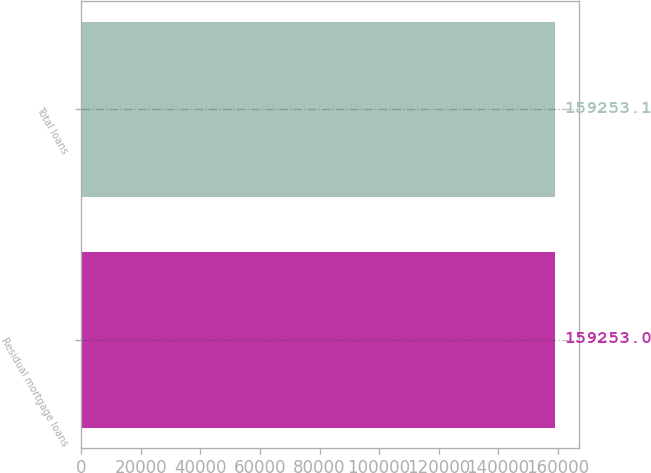Convert chart. <chart><loc_0><loc_0><loc_500><loc_500><bar_chart><fcel>Residual mortgage loans<fcel>Total loans<nl><fcel>159253<fcel>159253<nl></chart> 